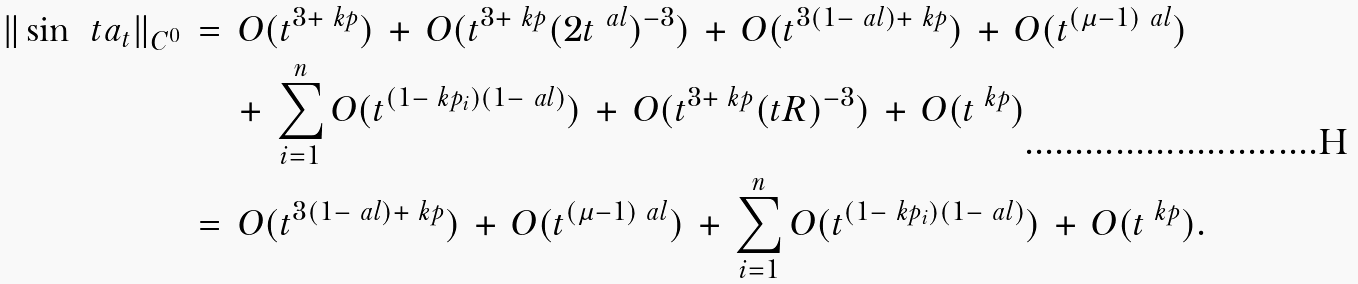<formula> <loc_0><loc_0><loc_500><loc_500>\| \sin \, \ t a _ { t } \| _ { C ^ { 0 } } \, & = \, O ( t ^ { 3 + \ k p } ) \, + \, O ( t ^ { 3 + \ k p } ( 2 t ^ { \ a l } ) ^ { - 3 } ) \, + \, O ( t ^ { 3 ( 1 - \ a l ) + \ k p } ) \, + \, O ( t ^ { ( \mu - 1 ) \ a l } ) \\ & \quad \, + \, \sum _ { i = 1 } ^ { n } O ( t ^ { ( 1 - \ k p _ { i } ) ( 1 - \ a l ) } ) \, + \, O ( t ^ { 3 + \ k p } ( t R ) ^ { - 3 } ) \, + \, O ( t ^ { \ k p } ) \\ & = \, O ( t ^ { 3 ( 1 - \ a l ) + \ k p } ) \, + \, O ( t ^ { ( \mu - 1 ) \ a l } ) \, + \, \sum _ { i = 1 } ^ { n } O ( t ^ { ( 1 - \ k p _ { i } ) ( 1 - \ a l ) } ) \, + \, O ( t ^ { \ k p } ) .</formula> 